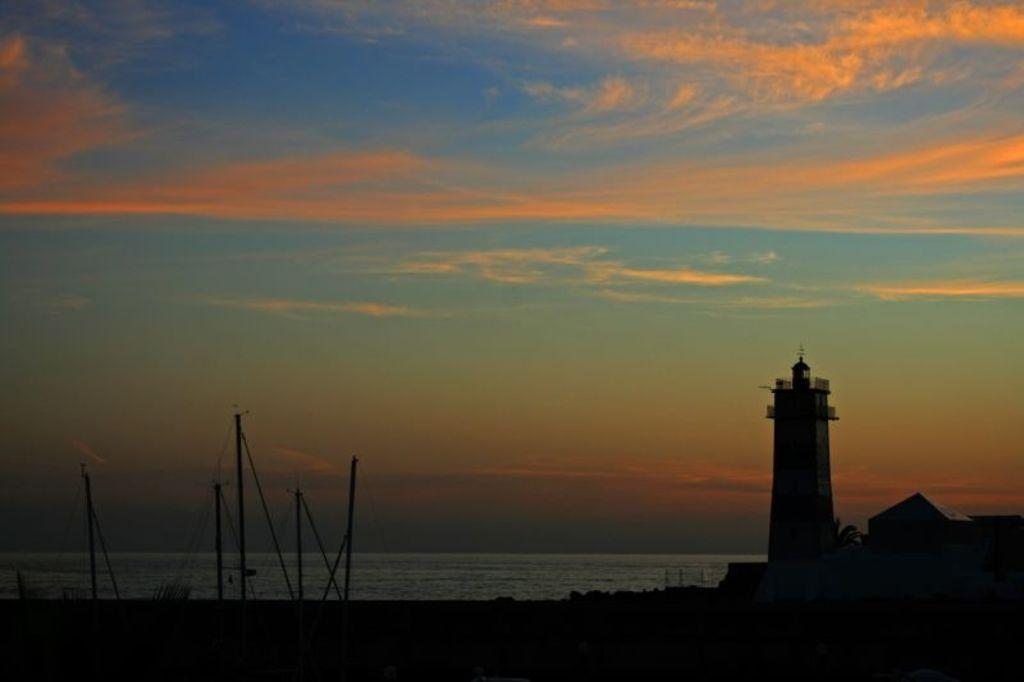Can you describe this image briefly? At the bottom of the picture, we see the poles. On the right side, we see a tower. Behind that, we see water and this water might be in the lake. At the top of the picture, we see the sky, which is in blue and orange color. 